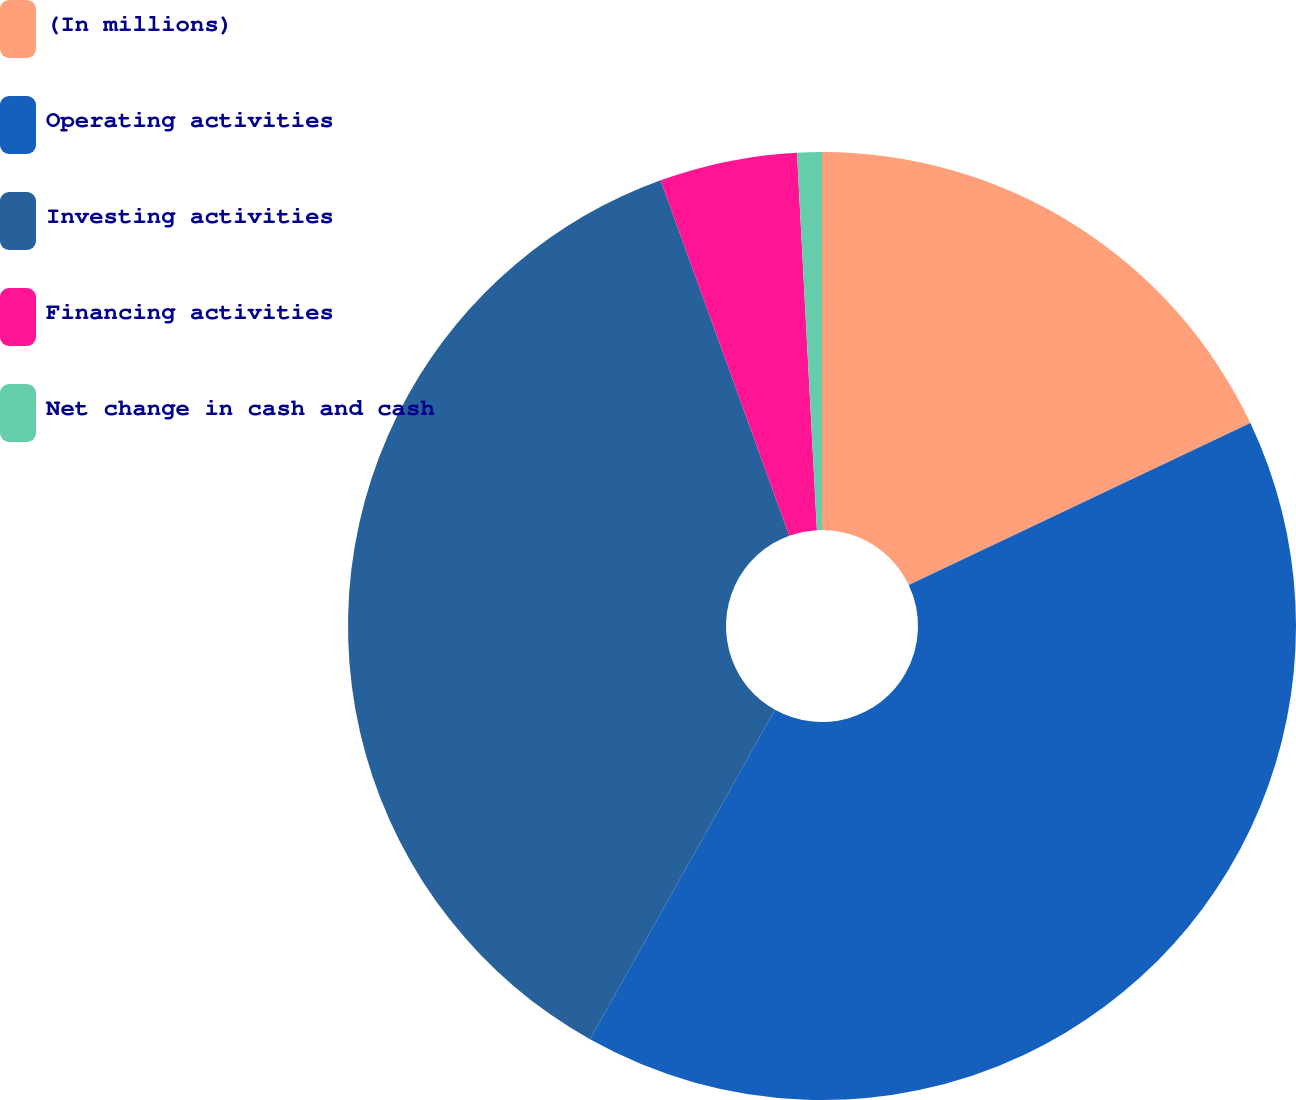Convert chart. <chart><loc_0><loc_0><loc_500><loc_500><pie_chart><fcel>(In millions)<fcel>Operating activities<fcel>Investing activities<fcel>Financing activities<fcel>Net change in cash and cash<nl><fcel>17.96%<fcel>40.18%<fcel>36.33%<fcel>4.69%<fcel>0.84%<nl></chart> 